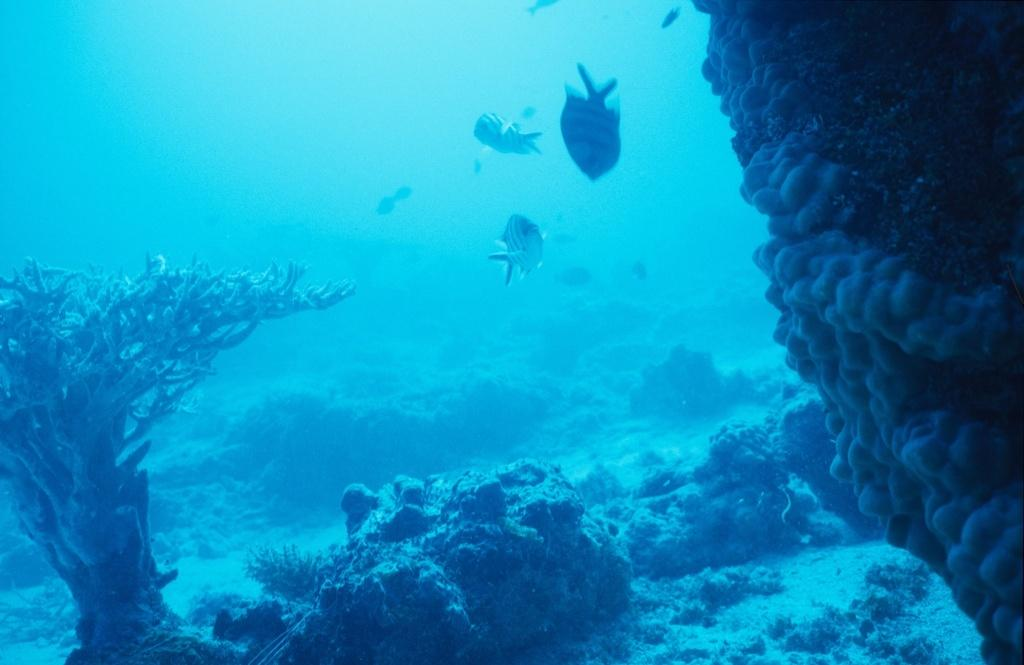Where is the picture taken? The picture is taken inside the water. What can be seen in the foreground of the image? There are coral reefs and water plants in the foreground of the image. What is located in the center of the image? There are fishes in the center of the image. What type of clover can be seen growing near the coral reefs in the image? There is no clover present in the image, as it is taken underwater and clover typically grows on land. 